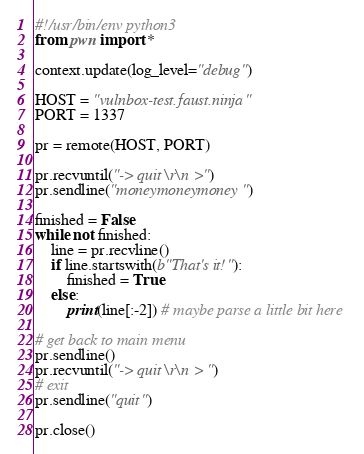<code> <loc_0><loc_0><loc_500><loc_500><_Python_>#!/usr/bin/env python3
from pwn import *

context.update(log_level="debug")

HOST = "vulnbox-test.faust.ninja"
PORT = 1337

pr = remote(HOST, PORT)

pr.recvuntil("-> quit\r\n  >")
pr.sendline("moneymoneymoney")

finished = False
while not finished:
    line = pr.recvline()
    if line.startswith(b"That's it!"):
        finished = True
    else:
        print(line[:-2]) # maybe parse a little bit here

# get back to main menu
pr.sendline()
pr.recvuntil("-> quit\r\n  > ")
# exit
pr.sendline("quit")

pr.close()
</code> 